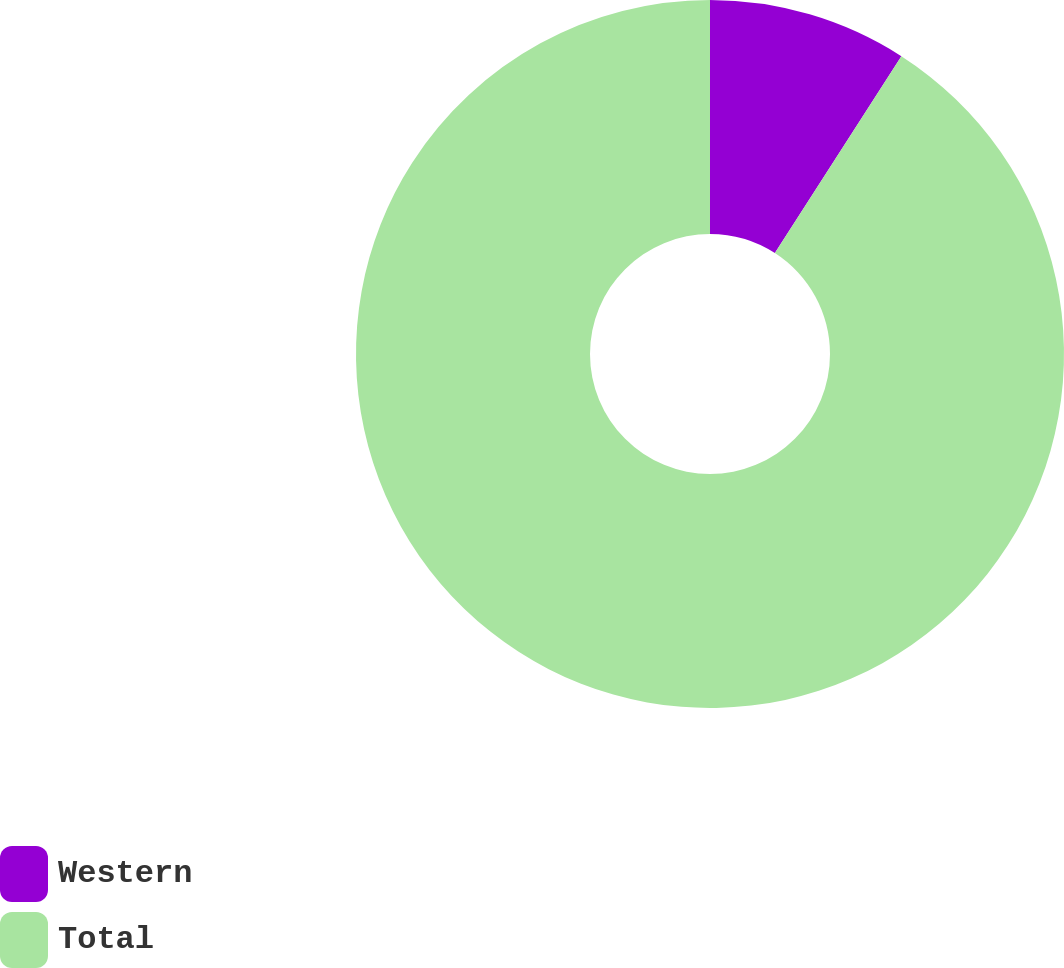Convert chart to OTSL. <chart><loc_0><loc_0><loc_500><loc_500><pie_chart><fcel>Western<fcel>Total<nl><fcel>9.09%<fcel>90.91%<nl></chart> 